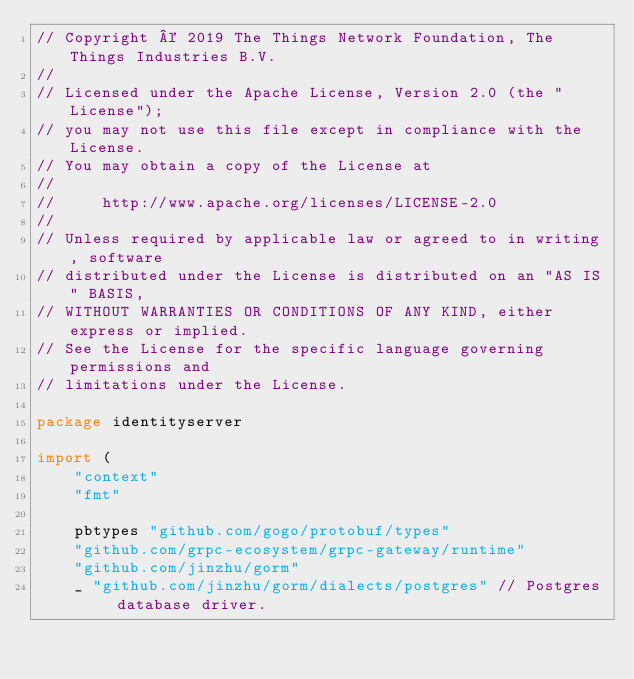<code> <loc_0><loc_0><loc_500><loc_500><_Go_>// Copyright © 2019 The Things Network Foundation, The Things Industries B.V.
//
// Licensed under the Apache License, Version 2.0 (the "License");
// you may not use this file except in compliance with the License.
// You may obtain a copy of the License at
//
//     http://www.apache.org/licenses/LICENSE-2.0
//
// Unless required by applicable law or agreed to in writing, software
// distributed under the License is distributed on an "AS IS" BASIS,
// WITHOUT WARRANTIES OR CONDITIONS OF ANY KIND, either express or implied.
// See the License for the specific language governing permissions and
// limitations under the License.

package identityserver

import (
	"context"
	"fmt"

	pbtypes "github.com/gogo/protobuf/types"
	"github.com/grpc-ecosystem/grpc-gateway/runtime"
	"github.com/jinzhu/gorm"
	_ "github.com/jinzhu/gorm/dialects/postgres" // Postgres database driver.</code> 